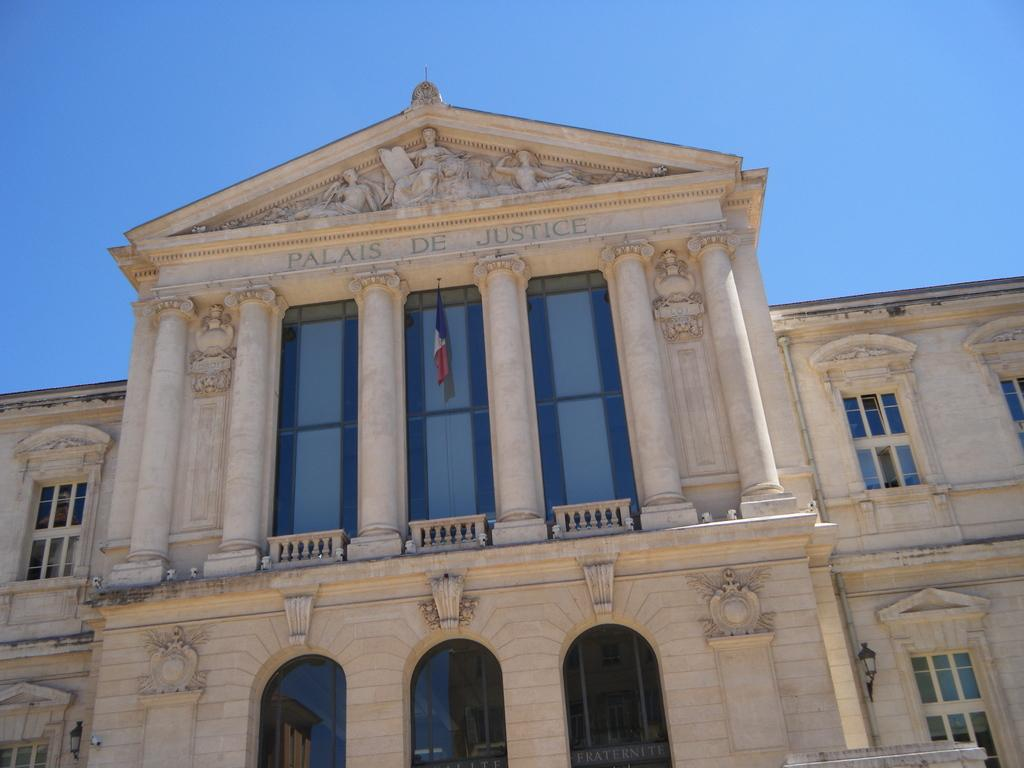What type of structure is present in the image? There is a building in the image. What feature can be seen on the building? The building has windows. What else is visible in the image besides the building? There are lights and a flag visible in the image. What is the color of the sky in the image? The sky is blue in color. Can you tell me how many toothbrushes are hanging on the flag in the image? There are no toothbrushes present in the image, and the flag does not have any toothbrushes hanging on it. 